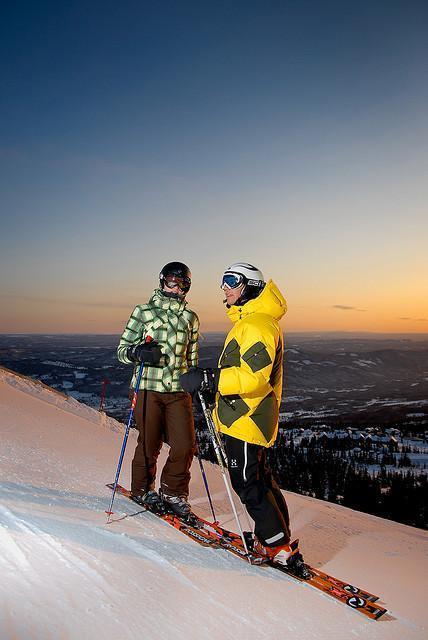How many skiers?
Give a very brief answer. 2. How many people are in the photo?
Give a very brief answer. 2. 